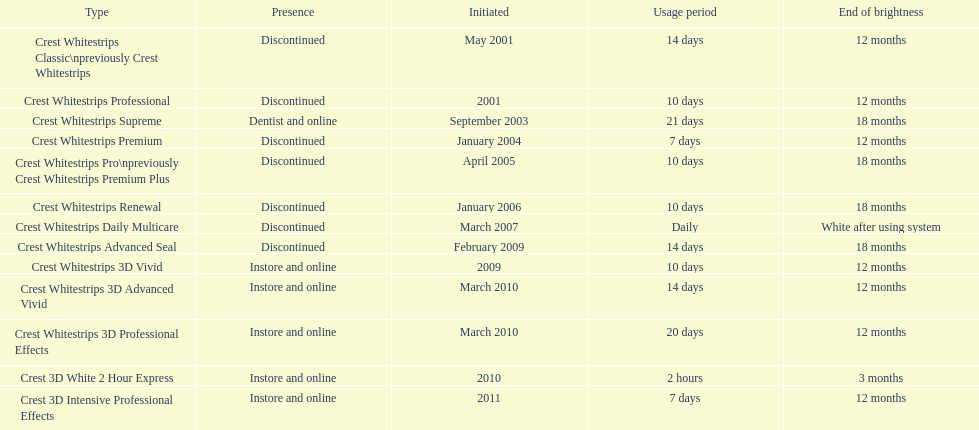Does the crest white strips pro last as long as the crest white strips renewal? Yes. 